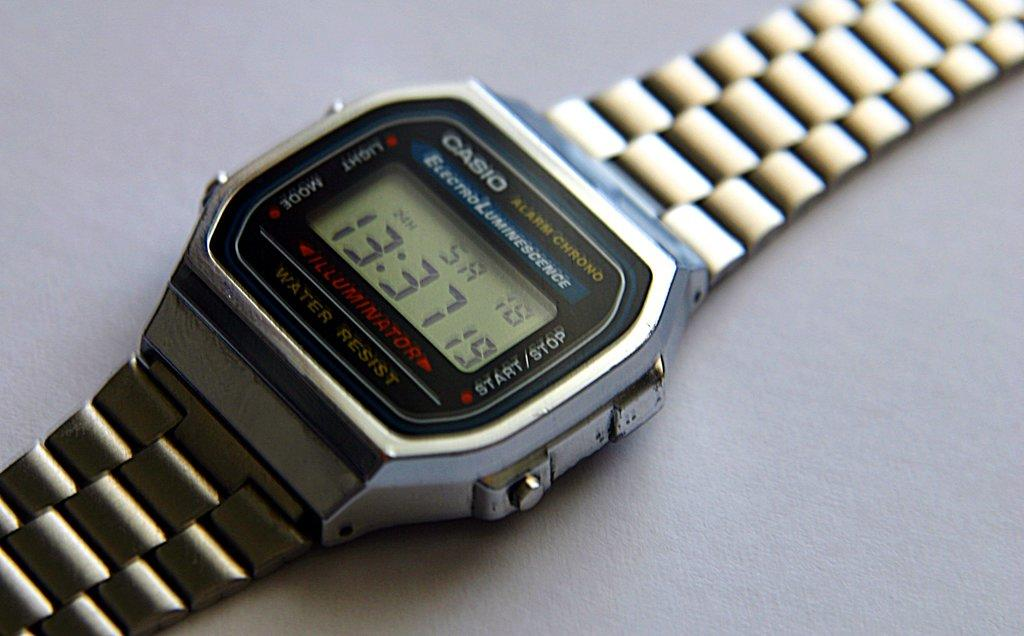<image>
Provide a brief description of the given image. the time of 13:37 that are on a watch 